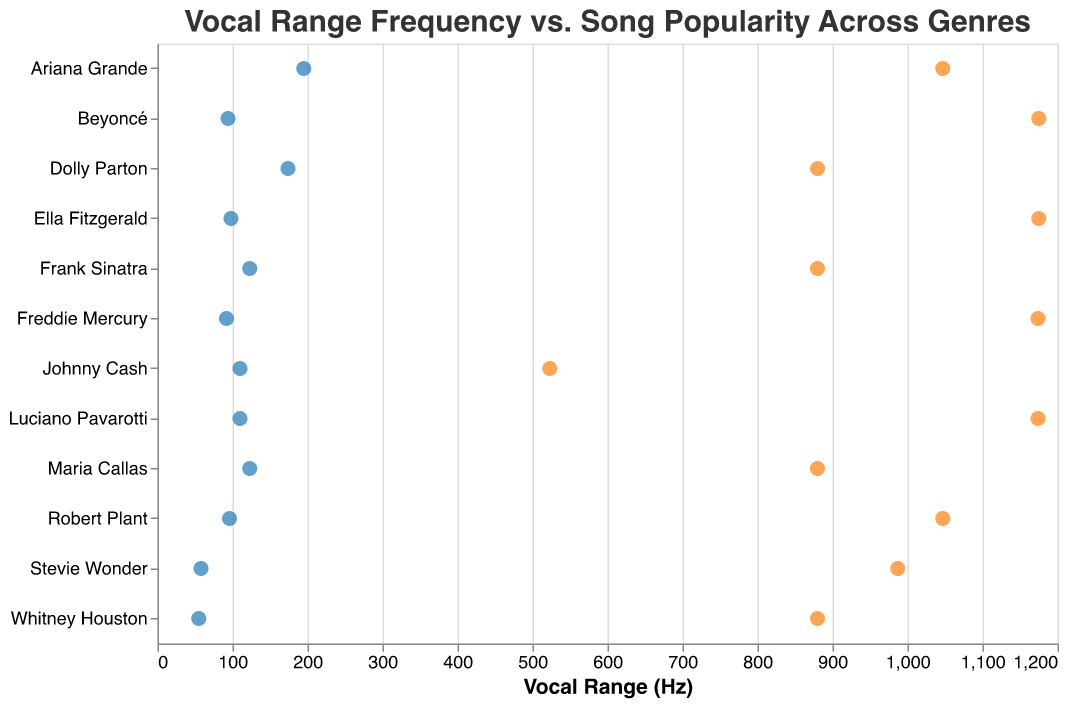What is the song with the highest popularity score? The highest popularity score can be found by looking for the highest value in the "Song Popularity Score" column. "Bohemian Rhapsody" by Freddie Mercury has a popularity score of 95, which is the highest.
Answer: Bohemian Rhapsody Which artist has the widest vocal range? To determine the widest vocal range, subtract the minimum value from the maximum value in the "Vocal Range (Hz)" for each artist. Freddie Mercury has a range of 1174-92 = 1082 Hz.
Answer: Freddie Mercury What's the average vocal range of the songs in the Rock genre? Look at the vocal ranges of Freddie Mercury (92-1174) and Robert Plant (96-1047). Calculate the average by summing up each of their ranges and dividing by two. [(1174-92) + (1047-96)]/2 = (1082 + 951)/2 = 1016.5
Answer: 1016.5 Hz Compare the vocal range of Beyoncé and Whitney Houston. Who has a higher maximum and who has a lower minimum? Beyoncé's vocal range is 94-1175 Hz and Whitney Houston's is 55-880 Hz. So, Beyoncé has a higher maximum (1175 > 880) and Whitney Houston has a lower minimum (55 < 94).
Answer: Beyoncé has a higher maximum, Whitney Houston has a lower minimum Which genre has the song with the lowest popularity score? Find the lowest popularity score and then identify the corresponding genre. Johnny Cash's "Ring of Fire" has a popularity score of 83, the lowest among all the songs. The genre is Country.
Answer: Country Is there a relationship between vocal range and song popularity? To determine the relationship, observe if songs with a broader or narrower vocal range tend to have specific popularity scores. Songs like "Bohemian Rhapsody" and "Nessun Dorma" have wide ranges and high popularity, suggesting a potential relationship.
Answer: Potential correlation; wide ranges can correlate with higher popularity Compare the vocal ranges of male and female artists in the Pop genre. Who has a wider range? In Pop, Ariana Grande's range is 195-1047 Hz and Whitney Houston's is 55-880 Hz. Comparing these: Ariana Grande's range is 852 Hz, and Whitney Houston's is 825 Hz. So, Ariana Grande has a wider range.
Answer: Ariana Grande 